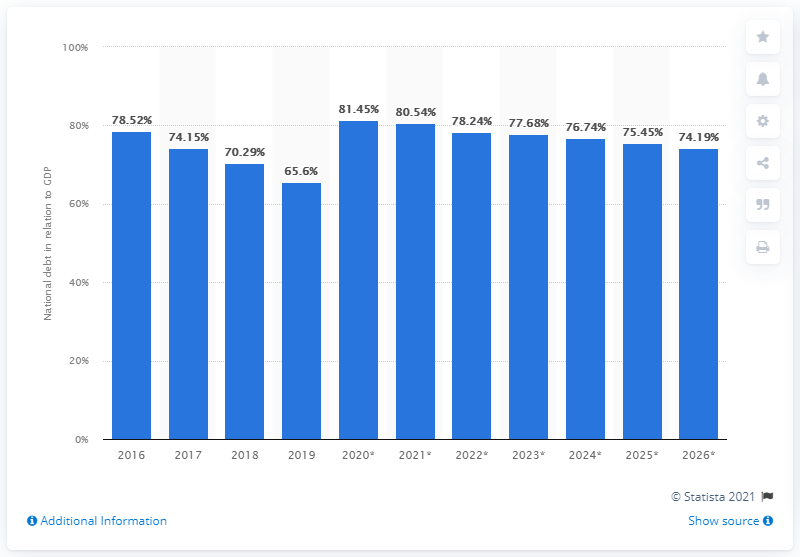Highlight a few significant elements in this photo. In 2019, the national debt of Slovenia accounted for 65.6% of the country's GDP. 